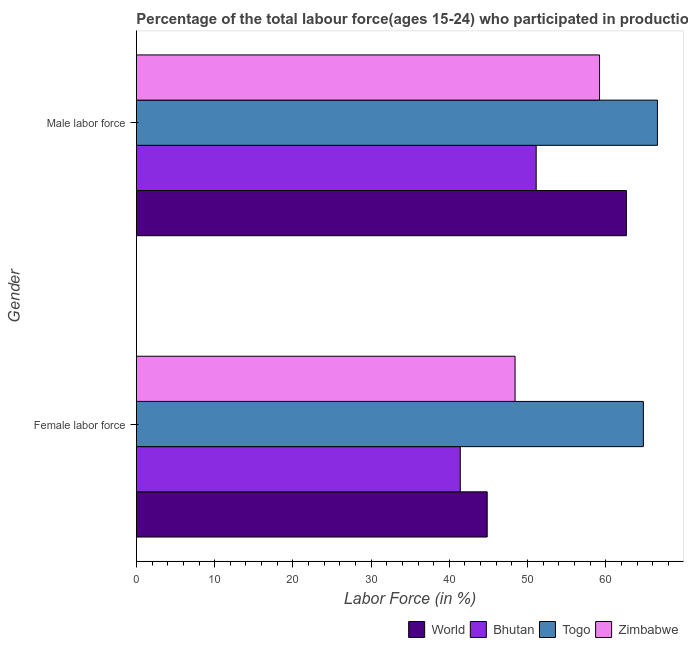Are the number of bars per tick equal to the number of legend labels?
Keep it short and to the point. Yes. Are the number of bars on each tick of the Y-axis equal?
Offer a very short reply. Yes. What is the label of the 2nd group of bars from the top?
Your answer should be very brief. Female labor force. What is the percentage of female labor force in Bhutan?
Offer a terse response. 41.4. Across all countries, what is the maximum percentage of female labor force?
Provide a succinct answer. 64.8. Across all countries, what is the minimum percentage of male labour force?
Offer a very short reply. 51.1. In which country was the percentage of female labor force maximum?
Provide a succinct answer. Togo. In which country was the percentage of male labour force minimum?
Provide a succinct answer. Bhutan. What is the total percentage of male labour force in the graph?
Your answer should be very brief. 239.53. What is the difference between the percentage of male labour force in Bhutan and that in Zimbabwe?
Ensure brevity in your answer.  -8.1. What is the difference between the percentage of female labor force in World and the percentage of male labour force in Zimbabwe?
Ensure brevity in your answer.  -14.36. What is the average percentage of female labor force per country?
Make the answer very short. 49.86. What is the difference between the percentage of female labor force and percentage of male labour force in Bhutan?
Give a very brief answer. -9.7. In how many countries, is the percentage of male labour force greater than 58 %?
Your response must be concise. 3. What is the ratio of the percentage of female labor force in Bhutan to that in World?
Your answer should be very brief. 0.92. In how many countries, is the percentage of female labor force greater than the average percentage of female labor force taken over all countries?
Give a very brief answer. 1. What does the 3rd bar from the top in Male labor force represents?
Offer a very short reply. Bhutan. What does the 3rd bar from the bottom in Male labor force represents?
Ensure brevity in your answer.  Togo. How many bars are there?
Give a very brief answer. 8. Are all the bars in the graph horizontal?
Provide a succinct answer. Yes. Does the graph contain any zero values?
Give a very brief answer. No. How are the legend labels stacked?
Offer a terse response. Horizontal. What is the title of the graph?
Give a very brief answer. Percentage of the total labour force(ages 15-24) who participated in production in 1999. What is the label or title of the Y-axis?
Offer a very short reply. Gender. What is the Labor Force (in %) of World in Female labor force?
Your answer should be very brief. 44.84. What is the Labor Force (in %) of Bhutan in Female labor force?
Provide a succinct answer. 41.4. What is the Labor Force (in %) in Togo in Female labor force?
Your answer should be compact. 64.8. What is the Labor Force (in %) of Zimbabwe in Female labor force?
Your response must be concise. 48.4. What is the Labor Force (in %) of World in Male labor force?
Offer a terse response. 62.63. What is the Labor Force (in %) in Bhutan in Male labor force?
Keep it short and to the point. 51.1. What is the Labor Force (in %) of Togo in Male labor force?
Make the answer very short. 66.6. What is the Labor Force (in %) in Zimbabwe in Male labor force?
Provide a short and direct response. 59.2. Across all Gender, what is the maximum Labor Force (in %) in World?
Offer a terse response. 62.63. Across all Gender, what is the maximum Labor Force (in %) of Bhutan?
Ensure brevity in your answer.  51.1. Across all Gender, what is the maximum Labor Force (in %) in Togo?
Make the answer very short. 66.6. Across all Gender, what is the maximum Labor Force (in %) in Zimbabwe?
Provide a short and direct response. 59.2. Across all Gender, what is the minimum Labor Force (in %) in World?
Keep it short and to the point. 44.84. Across all Gender, what is the minimum Labor Force (in %) in Bhutan?
Your answer should be compact. 41.4. Across all Gender, what is the minimum Labor Force (in %) in Togo?
Offer a very short reply. 64.8. Across all Gender, what is the minimum Labor Force (in %) of Zimbabwe?
Your response must be concise. 48.4. What is the total Labor Force (in %) of World in the graph?
Your response must be concise. 107.47. What is the total Labor Force (in %) of Bhutan in the graph?
Offer a terse response. 92.5. What is the total Labor Force (in %) of Togo in the graph?
Ensure brevity in your answer.  131.4. What is the total Labor Force (in %) of Zimbabwe in the graph?
Offer a very short reply. 107.6. What is the difference between the Labor Force (in %) in World in Female labor force and that in Male labor force?
Provide a short and direct response. -17.79. What is the difference between the Labor Force (in %) of Togo in Female labor force and that in Male labor force?
Your answer should be very brief. -1.8. What is the difference between the Labor Force (in %) in Zimbabwe in Female labor force and that in Male labor force?
Your answer should be very brief. -10.8. What is the difference between the Labor Force (in %) of World in Female labor force and the Labor Force (in %) of Bhutan in Male labor force?
Offer a very short reply. -6.26. What is the difference between the Labor Force (in %) in World in Female labor force and the Labor Force (in %) in Togo in Male labor force?
Provide a short and direct response. -21.76. What is the difference between the Labor Force (in %) in World in Female labor force and the Labor Force (in %) in Zimbabwe in Male labor force?
Offer a very short reply. -14.36. What is the difference between the Labor Force (in %) of Bhutan in Female labor force and the Labor Force (in %) of Togo in Male labor force?
Provide a succinct answer. -25.2. What is the difference between the Labor Force (in %) of Bhutan in Female labor force and the Labor Force (in %) of Zimbabwe in Male labor force?
Ensure brevity in your answer.  -17.8. What is the difference between the Labor Force (in %) in Togo in Female labor force and the Labor Force (in %) in Zimbabwe in Male labor force?
Provide a short and direct response. 5.6. What is the average Labor Force (in %) in World per Gender?
Your answer should be very brief. 53.73. What is the average Labor Force (in %) of Bhutan per Gender?
Provide a short and direct response. 46.25. What is the average Labor Force (in %) of Togo per Gender?
Keep it short and to the point. 65.7. What is the average Labor Force (in %) in Zimbabwe per Gender?
Provide a short and direct response. 53.8. What is the difference between the Labor Force (in %) in World and Labor Force (in %) in Bhutan in Female labor force?
Your answer should be compact. 3.44. What is the difference between the Labor Force (in %) in World and Labor Force (in %) in Togo in Female labor force?
Keep it short and to the point. -19.96. What is the difference between the Labor Force (in %) in World and Labor Force (in %) in Zimbabwe in Female labor force?
Your answer should be very brief. -3.56. What is the difference between the Labor Force (in %) in Bhutan and Labor Force (in %) in Togo in Female labor force?
Ensure brevity in your answer.  -23.4. What is the difference between the Labor Force (in %) in World and Labor Force (in %) in Bhutan in Male labor force?
Give a very brief answer. 11.53. What is the difference between the Labor Force (in %) of World and Labor Force (in %) of Togo in Male labor force?
Give a very brief answer. -3.97. What is the difference between the Labor Force (in %) in World and Labor Force (in %) in Zimbabwe in Male labor force?
Offer a very short reply. 3.43. What is the difference between the Labor Force (in %) of Bhutan and Labor Force (in %) of Togo in Male labor force?
Provide a succinct answer. -15.5. What is the difference between the Labor Force (in %) of Bhutan and Labor Force (in %) of Zimbabwe in Male labor force?
Keep it short and to the point. -8.1. What is the ratio of the Labor Force (in %) in World in Female labor force to that in Male labor force?
Keep it short and to the point. 0.72. What is the ratio of the Labor Force (in %) in Bhutan in Female labor force to that in Male labor force?
Provide a succinct answer. 0.81. What is the ratio of the Labor Force (in %) of Togo in Female labor force to that in Male labor force?
Provide a short and direct response. 0.97. What is the ratio of the Labor Force (in %) in Zimbabwe in Female labor force to that in Male labor force?
Your answer should be compact. 0.82. What is the difference between the highest and the second highest Labor Force (in %) in World?
Make the answer very short. 17.79. What is the difference between the highest and the second highest Labor Force (in %) in Bhutan?
Offer a terse response. 9.7. What is the difference between the highest and the lowest Labor Force (in %) of World?
Ensure brevity in your answer.  17.79. What is the difference between the highest and the lowest Labor Force (in %) of Togo?
Your response must be concise. 1.8. What is the difference between the highest and the lowest Labor Force (in %) in Zimbabwe?
Make the answer very short. 10.8. 